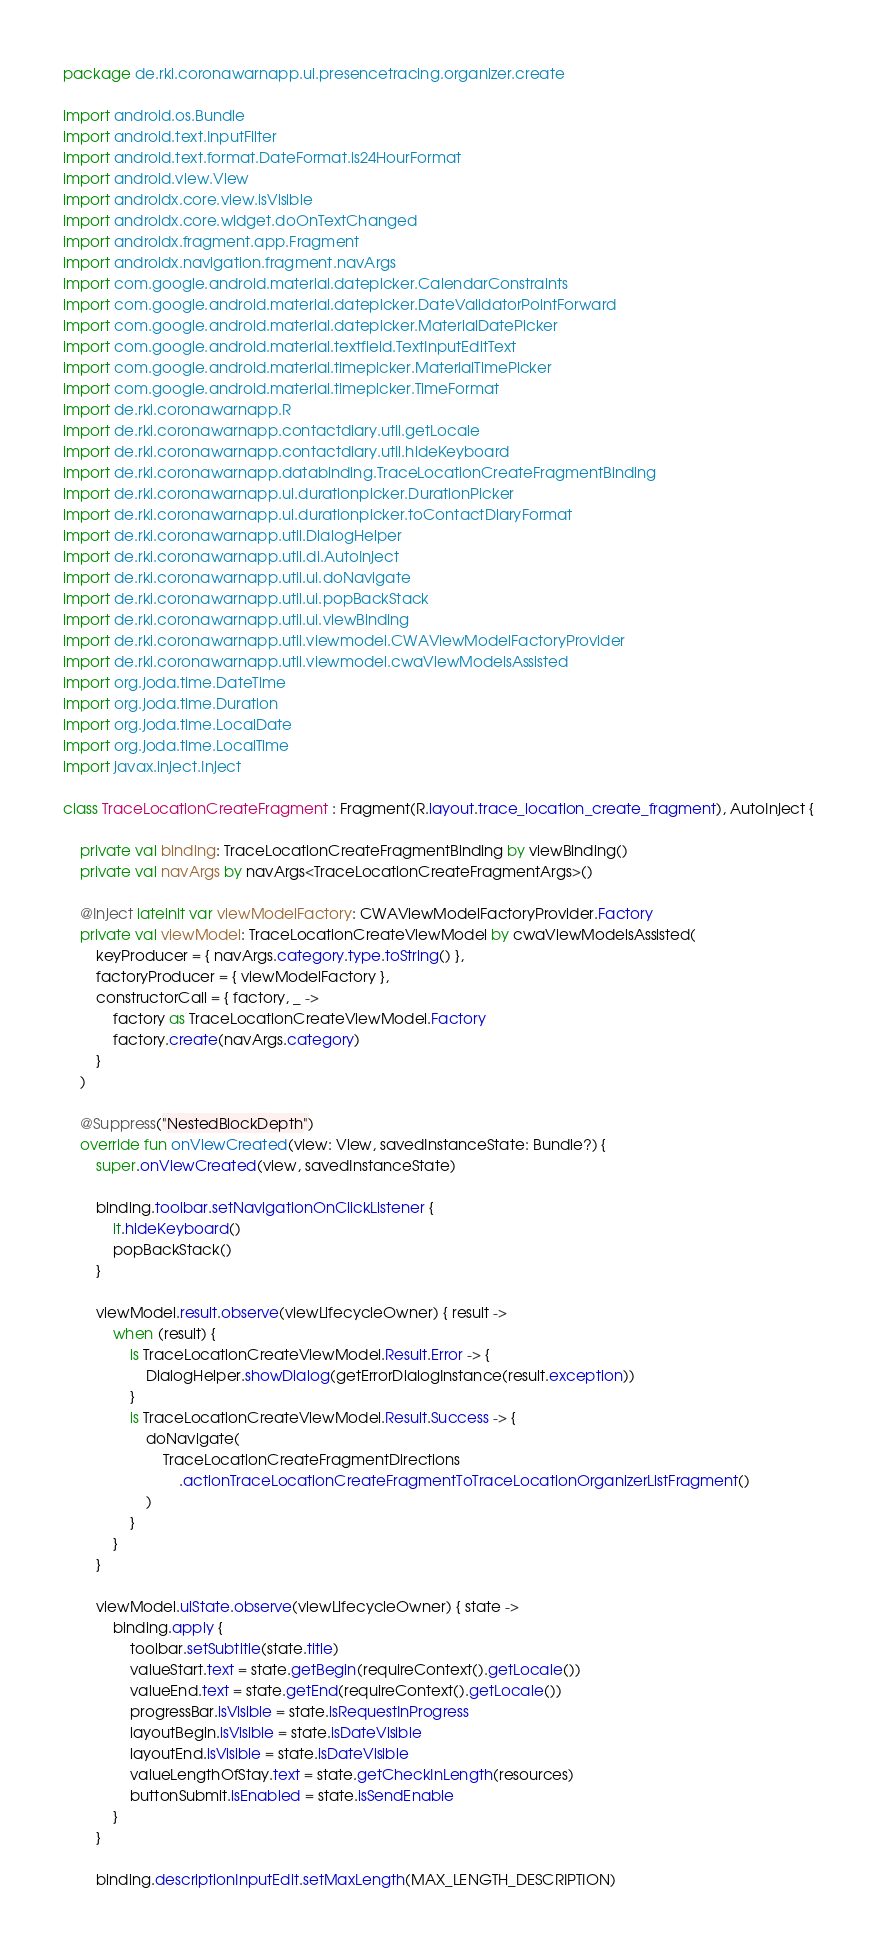Convert code to text. <code><loc_0><loc_0><loc_500><loc_500><_Kotlin_>package de.rki.coronawarnapp.ui.presencetracing.organizer.create

import android.os.Bundle
import android.text.InputFilter
import android.text.format.DateFormat.is24HourFormat
import android.view.View
import androidx.core.view.isVisible
import androidx.core.widget.doOnTextChanged
import androidx.fragment.app.Fragment
import androidx.navigation.fragment.navArgs
import com.google.android.material.datepicker.CalendarConstraints
import com.google.android.material.datepicker.DateValidatorPointForward
import com.google.android.material.datepicker.MaterialDatePicker
import com.google.android.material.textfield.TextInputEditText
import com.google.android.material.timepicker.MaterialTimePicker
import com.google.android.material.timepicker.TimeFormat
import de.rki.coronawarnapp.R
import de.rki.coronawarnapp.contactdiary.util.getLocale
import de.rki.coronawarnapp.contactdiary.util.hideKeyboard
import de.rki.coronawarnapp.databinding.TraceLocationCreateFragmentBinding
import de.rki.coronawarnapp.ui.durationpicker.DurationPicker
import de.rki.coronawarnapp.ui.durationpicker.toContactDiaryFormat
import de.rki.coronawarnapp.util.DialogHelper
import de.rki.coronawarnapp.util.di.AutoInject
import de.rki.coronawarnapp.util.ui.doNavigate
import de.rki.coronawarnapp.util.ui.popBackStack
import de.rki.coronawarnapp.util.ui.viewBinding
import de.rki.coronawarnapp.util.viewmodel.CWAViewModelFactoryProvider
import de.rki.coronawarnapp.util.viewmodel.cwaViewModelsAssisted
import org.joda.time.DateTime
import org.joda.time.Duration
import org.joda.time.LocalDate
import org.joda.time.LocalTime
import javax.inject.Inject

class TraceLocationCreateFragment : Fragment(R.layout.trace_location_create_fragment), AutoInject {

    private val binding: TraceLocationCreateFragmentBinding by viewBinding()
    private val navArgs by navArgs<TraceLocationCreateFragmentArgs>()

    @Inject lateinit var viewModelFactory: CWAViewModelFactoryProvider.Factory
    private val viewModel: TraceLocationCreateViewModel by cwaViewModelsAssisted(
        keyProducer = { navArgs.category.type.toString() },
        factoryProducer = { viewModelFactory },
        constructorCall = { factory, _ ->
            factory as TraceLocationCreateViewModel.Factory
            factory.create(navArgs.category)
        }
    )

    @Suppress("NestedBlockDepth")
    override fun onViewCreated(view: View, savedInstanceState: Bundle?) {
        super.onViewCreated(view, savedInstanceState)

        binding.toolbar.setNavigationOnClickListener {
            it.hideKeyboard()
            popBackStack()
        }

        viewModel.result.observe(viewLifecycleOwner) { result ->
            when (result) {
                is TraceLocationCreateViewModel.Result.Error -> {
                    DialogHelper.showDialog(getErrorDialogInstance(result.exception))
                }
                is TraceLocationCreateViewModel.Result.Success -> {
                    doNavigate(
                        TraceLocationCreateFragmentDirections
                            .actionTraceLocationCreateFragmentToTraceLocationOrganizerListFragment()
                    )
                }
            }
        }

        viewModel.uiState.observe(viewLifecycleOwner) { state ->
            binding.apply {
                toolbar.setSubtitle(state.title)
                valueStart.text = state.getBegin(requireContext().getLocale())
                valueEnd.text = state.getEnd(requireContext().getLocale())
                progressBar.isVisible = state.isRequestInProgress
                layoutBegin.isVisible = state.isDateVisible
                layoutEnd.isVisible = state.isDateVisible
                valueLengthOfStay.text = state.getCheckInLength(resources)
                buttonSubmit.isEnabled = state.isSendEnable
            }
        }

        binding.descriptionInputEdit.setMaxLength(MAX_LENGTH_DESCRIPTION)</code> 